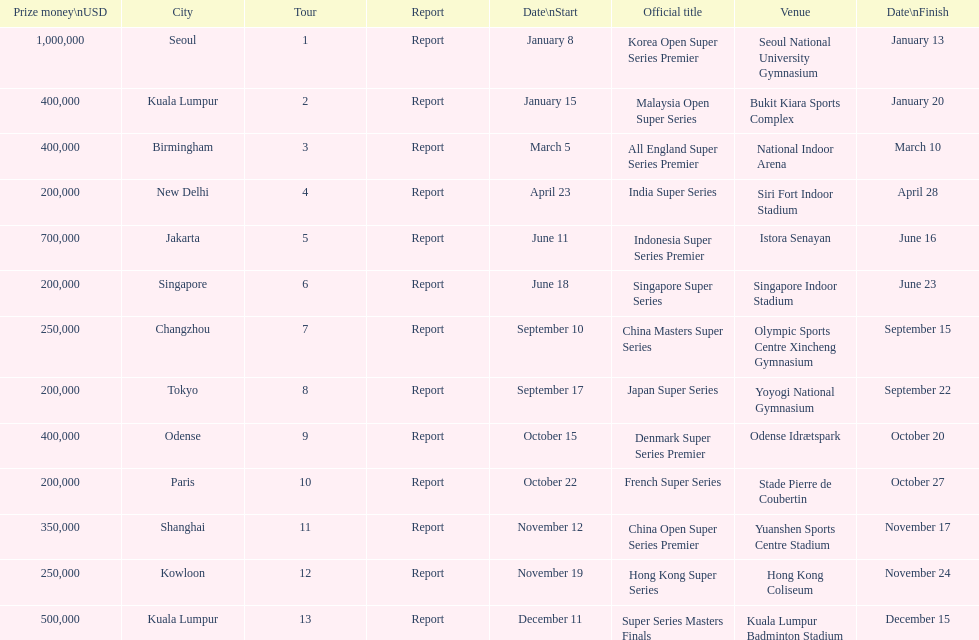How many tours took place during january? 2. 